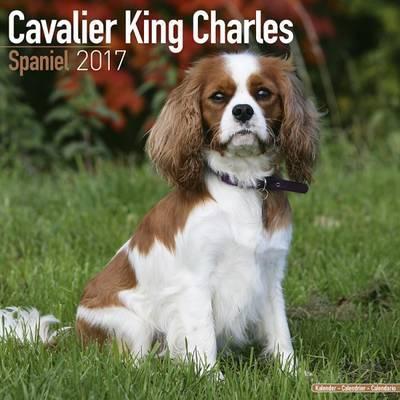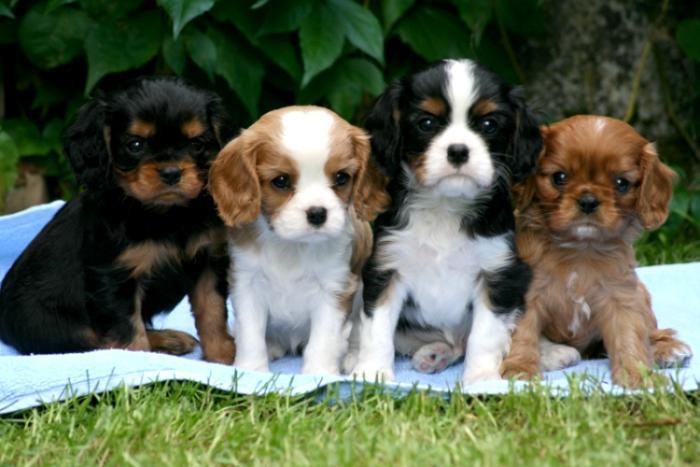The first image is the image on the left, the second image is the image on the right. Assess this claim about the two images: "The right image contains exactly four dogs seated in a horizontal row.". Correct or not? Answer yes or no. Yes. The first image is the image on the left, the second image is the image on the right. Evaluate the accuracy of this statement regarding the images: "A horizontal row of four spaniels in similar poses includes dogs of different colors.". Is it true? Answer yes or no. Yes. 